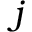Convert formula to latex. <formula><loc_0><loc_0><loc_500><loc_500>j</formula> 